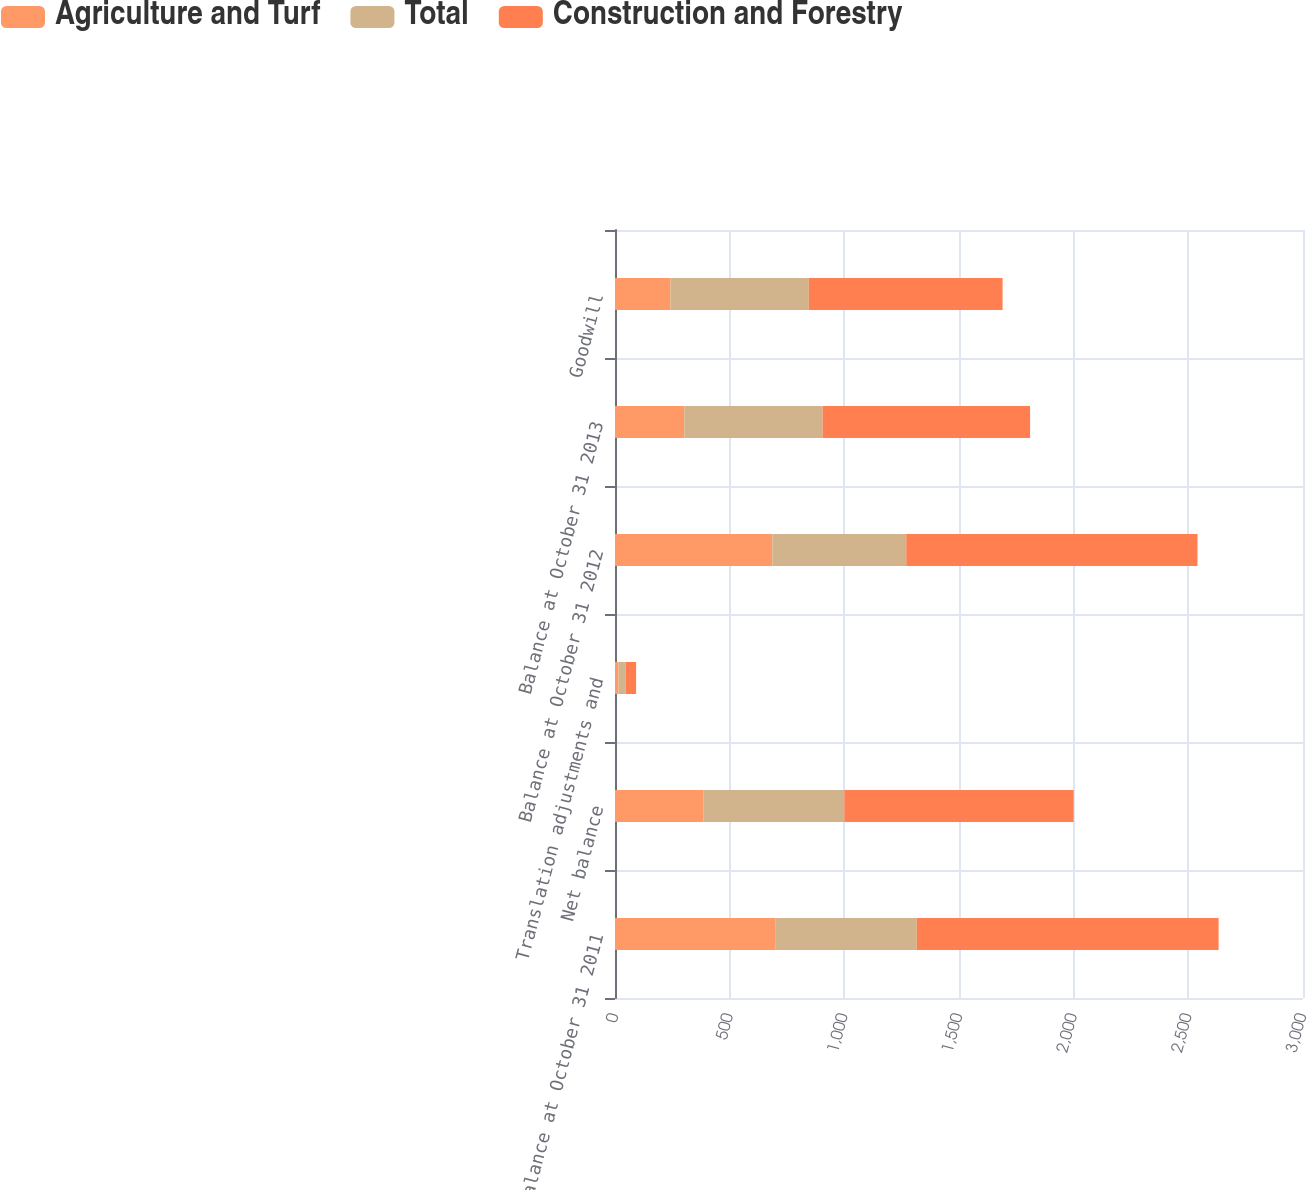<chart> <loc_0><loc_0><loc_500><loc_500><stacked_bar_chart><ecel><fcel>Balance at October 31 2011<fcel>Net balance<fcel>Translation adjustments and<fcel>Balance at October 31 2012<fcel>Balance at October 31 2013<fcel>Goodwill<nl><fcel>Agriculture and Turf<fcel>701<fcel>385<fcel>15<fcel>686<fcel>302<fcel>242<nl><fcel>Total<fcel>615<fcel>615<fcel>31<fcel>584<fcel>603<fcel>603<nl><fcel>Construction and Forestry<fcel>1316<fcel>1000<fcel>46<fcel>1270<fcel>905<fcel>845<nl></chart> 